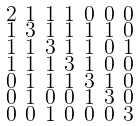<formula> <loc_0><loc_0><loc_500><loc_500>\begin{smallmatrix} 2 & 1 & 1 & 1 & 0 & 0 & 0 \\ 1 & 3 & 1 & 1 & 1 & 1 & 0 \\ 1 & 1 & 3 & 1 & 1 & 0 & 1 \\ 1 & 1 & 1 & 3 & 1 & 0 & 0 \\ 0 & 1 & 1 & 1 & 3 & 1 & 0 \\ 0 & 1 & 0 & 0 & 1 & 3 & 0 \\ 0 & 0 & 1 & 0 & 0 & 0 & 3 \end{smallmatrix}</formula> 